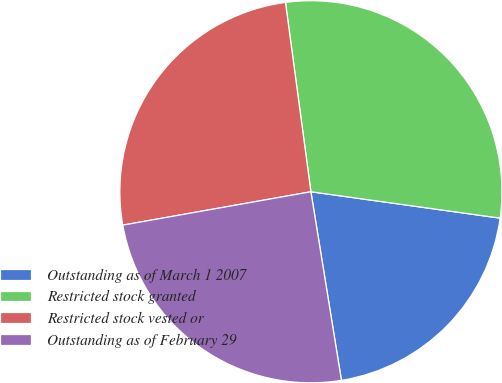<chart> <loc_0><loc_0><loc_500><loc_500><pie_chart><fcel>Outstanding as of March 1 2007<fcel>Restricted stock granted<fcel>Restricted stock vested or<fcel>Outstanding as of February 29<nl><fcel>20.24%<fcel>29.33%<fcel>25.67%<fcel>24.76%<nl></chart> 